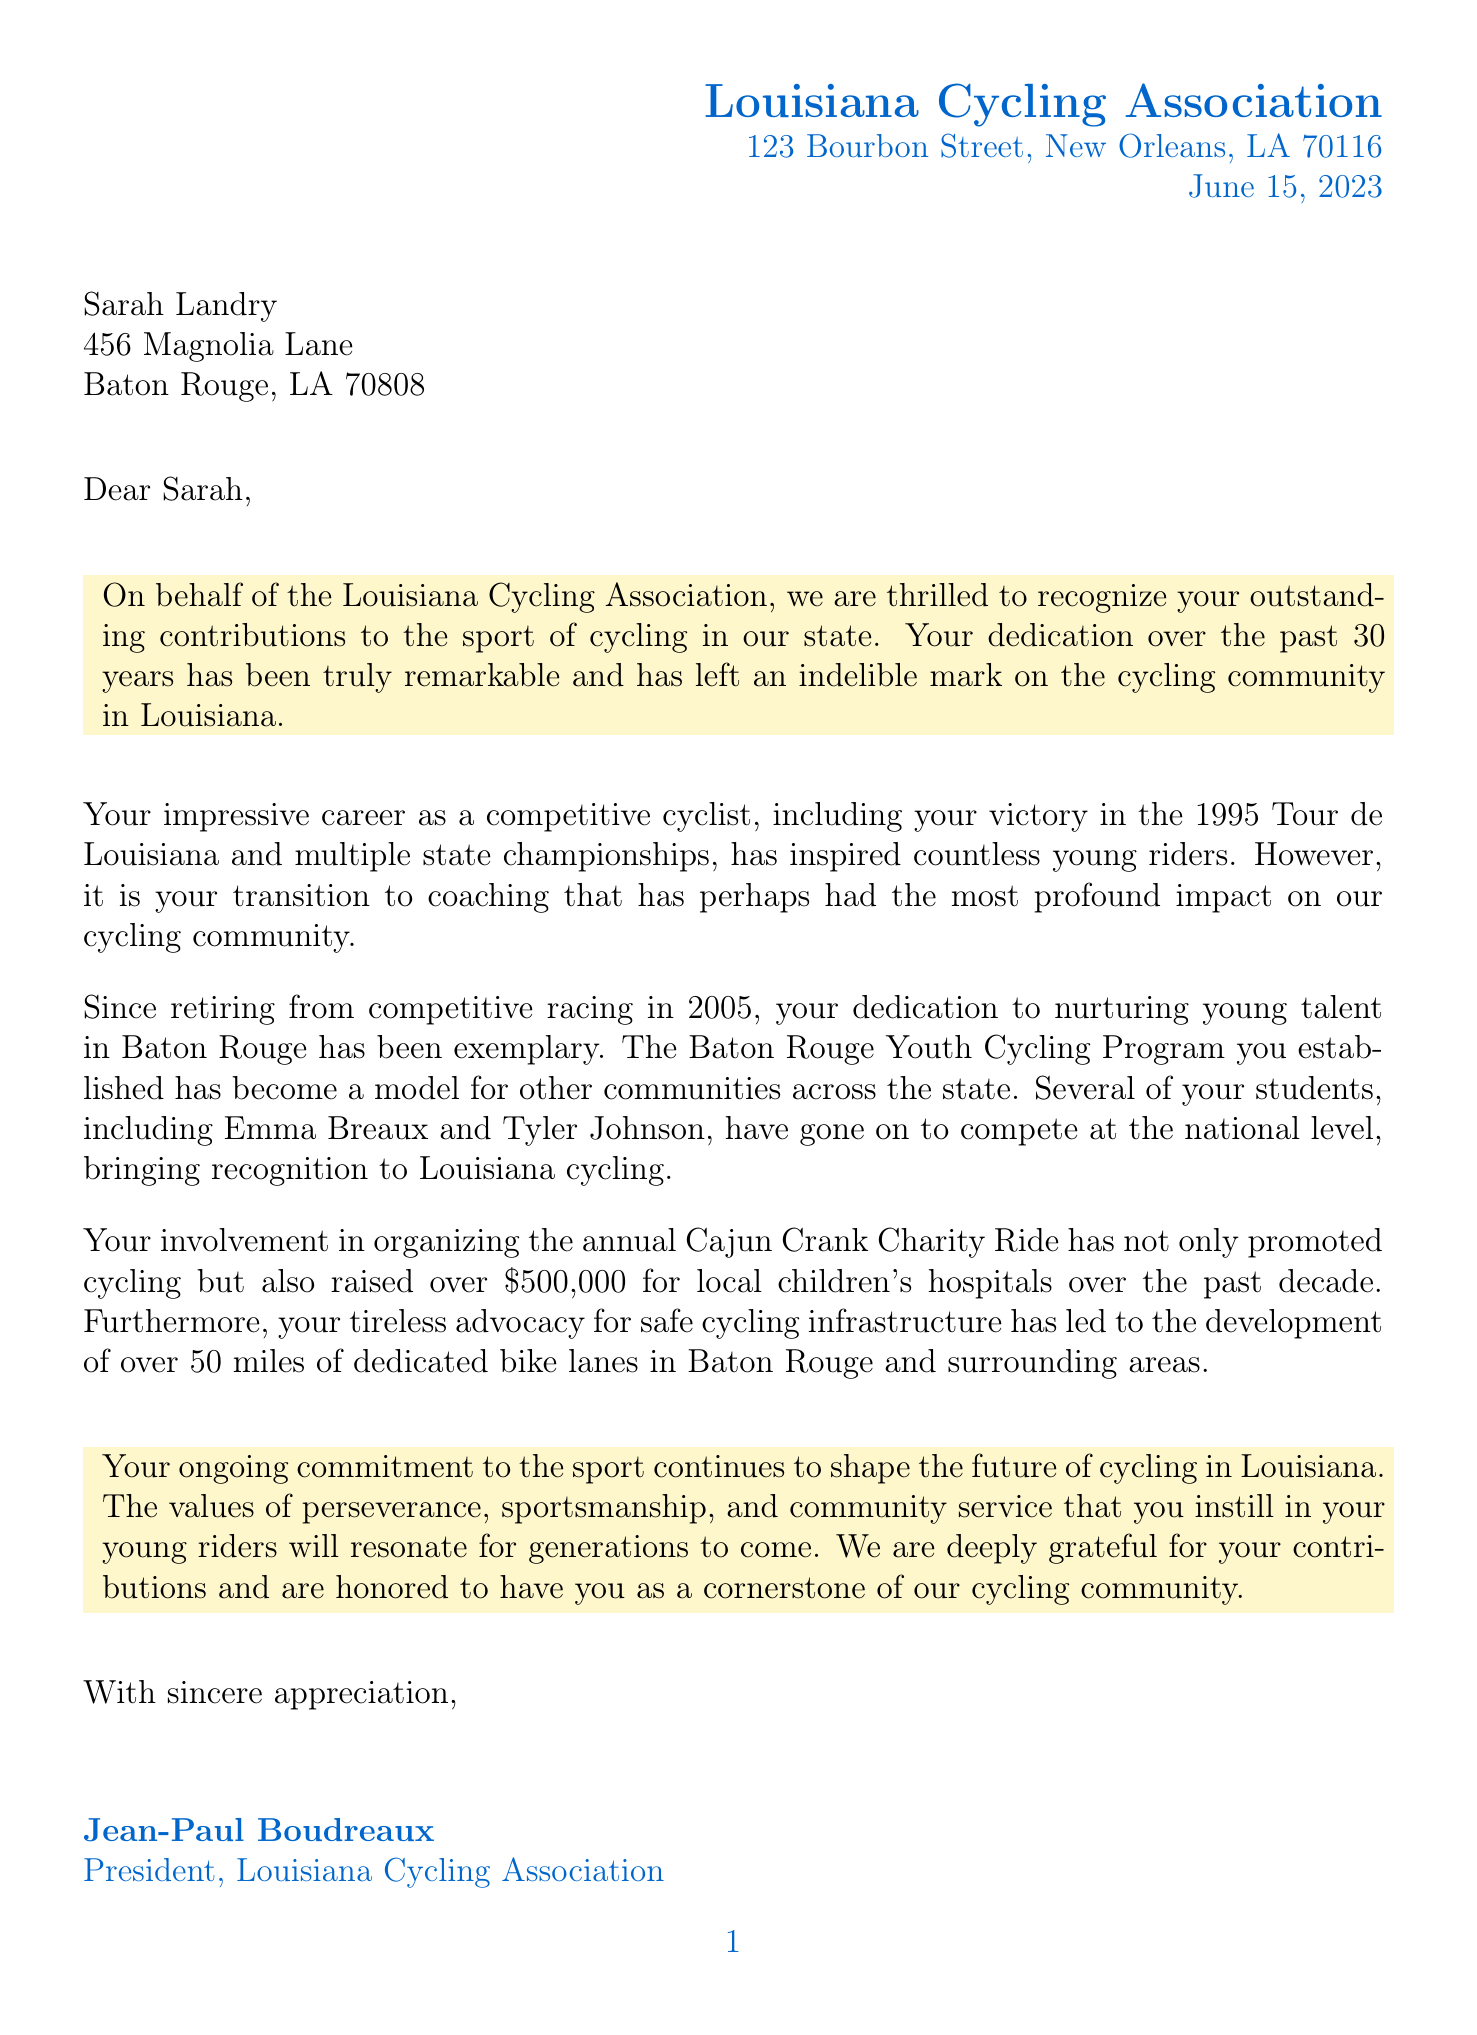What is the name of the association? The letter is from the Louisiana Cycling Association, which is mentioned in the header of the document.
Answer: Louisiana Cycling Association What is the date of the letter? The date of the letter is located at the top of the document and indicates when it was written.
Answer: June 15, 2023 Who is the recipient of the letter? The letter addresses Sarah Landry, providing her name in the recipient information section.
Answer: Sarah Landry How many years of service does the letter recognize? The letter states that Sarah has contributed to the sport for 30 years, specified in the opening paragraph.
Answer: 30 years What was one of Sarah's competitive achievements? The letter mentions her victory in the 1995 Tour de Louisiana as a highlight of her competitive cycling career.
Answer: 1995 Tour de Louisiana What program did Sarah establish for young riders? In the document, it is indicated that Sarah established the Baton Rouge Youth Cycling Program.
Answer: Baton Rouge Youth Cycling Program How much money has the Cajun Crank Charity Ride raised? The letter notes that over $500,000 has been raised for local children's hospitals through the Cajun Crank Charity Ride.
Answer: $500,000 What is the upcoming event mentioned in the postscript? The postscript mentions an upcoming event that Sarah and her team are expected to attend.
Answer: Louisiana Junior Cycling Championships Who signed the letter? The signature section reveals that the letter was signed by the President of the Louisiana Cycling Association.
Answer: Jean-Paul Boudreaux 